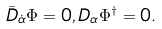Convert formula to latex. <formula><loc_0><loc_0><loc_500><loc_500>\bar { D } _ { \dot { \alpha } } \Phi = 0 , D _ { \alpha } \Phi ^ { \dagger } = 0 .</formula> 